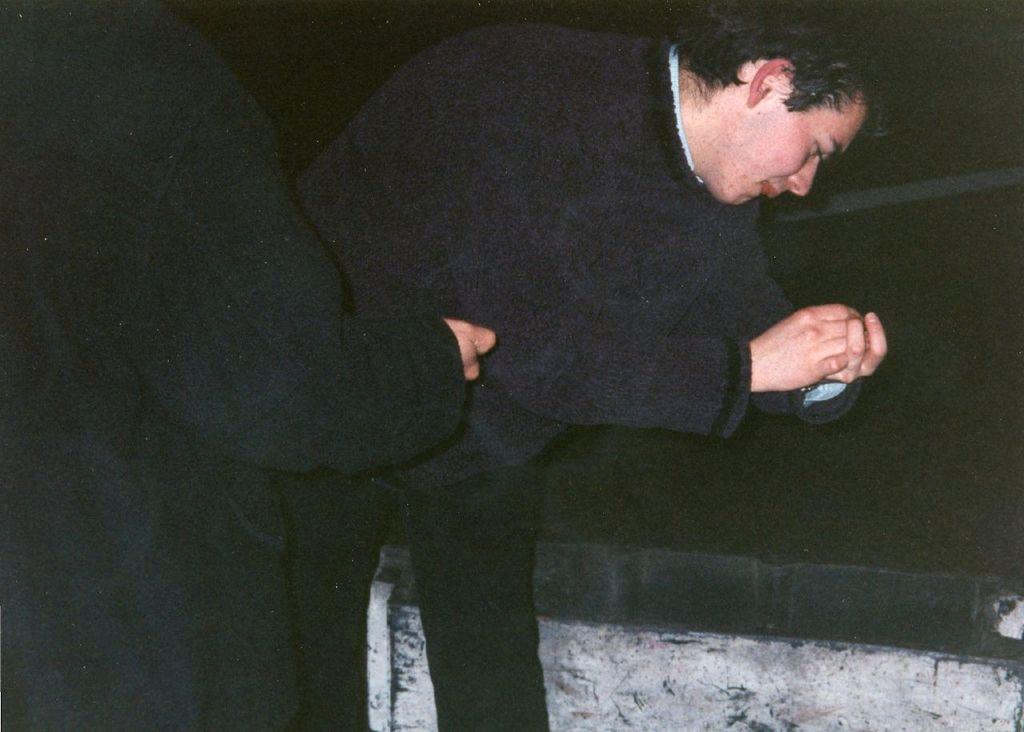How many people are present in the image? There are two people in the image. What can be seen in the background of the image? The background of the image is dark. Is there any structure or object in the image besides the people? Yes, there is a wall in the image. What type of dinner is being served in the image? There is no dinner present in the image; it only features two people and a wall. 